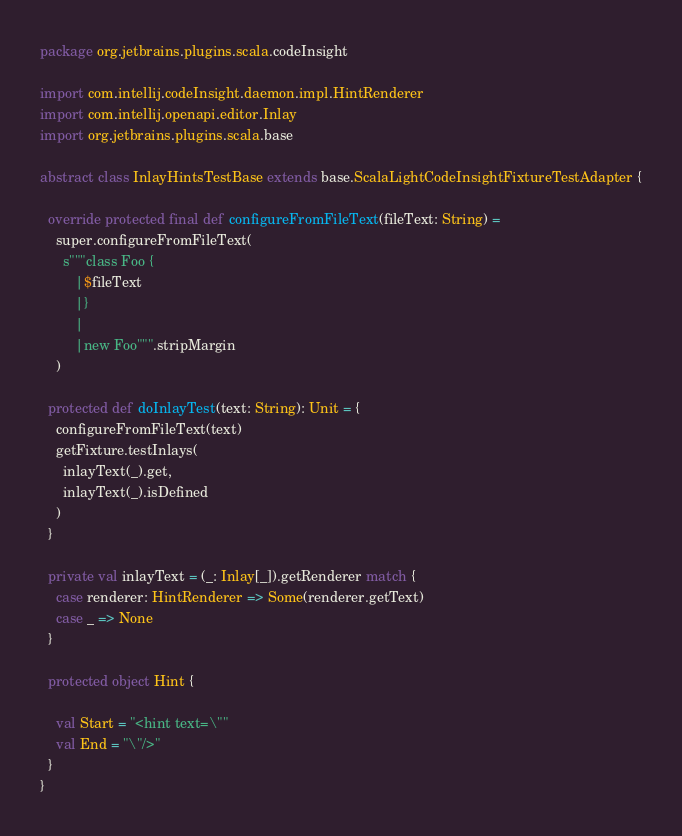Convert code to text. <code><loc_0><loc_0><loc_500><loc_500><_Scala_>package org.jetbrains.plugins.scala.codeInsight

import com.intellij.codeInsight.daemon.impl.HintRenderer
import com.intellij.openapi.editor.Inlay
import org.jetbrains.plugins.scala.base

abstract class InlayHintsTestBase extends base.ScalaLightCodeInsightFixtureTestAdapter {

  override protected final def configureFromFileText(fileText: String) =
    super.configureFromFileText(
      s"""class Foo {
         |$fileText
         |}
         |
         |new Foo""".stripMargin
    )

  protected def doInlayTest(text: String): Unit = {
    configureFromFileText(text)
    getFixture.testInlays(
      inlayText(_).get,
      inlayText(_).isDefined
    )
  }

  private val inlayText = (_: Inlay[_]).getRenderer match {
    case renderer: HintRenderer => Some(renderer.getText)
    case _ => None
  }

  protected object Hint {

    val Start = "<hint text=\""
    val End = "\"/>"
  }
}
</code> 